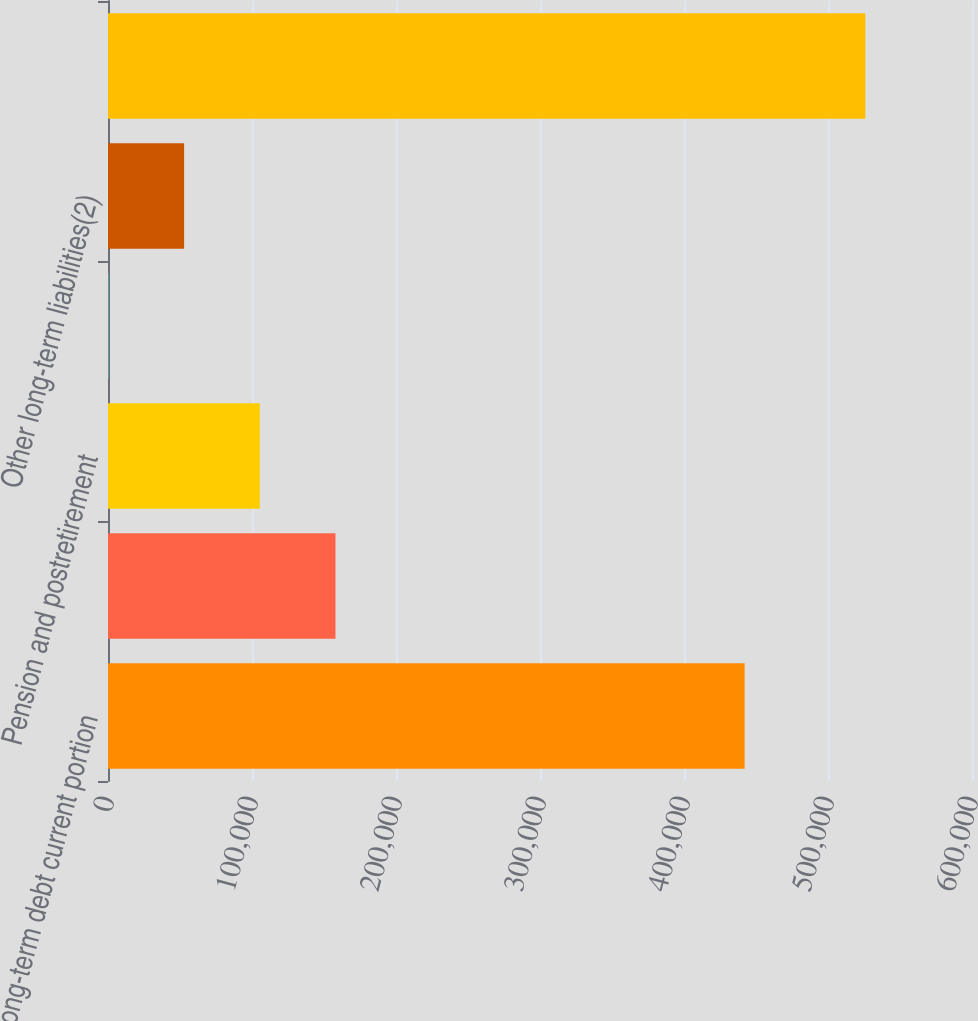Convert chart to OTSL. <chart><loc_0><loc_0><loc_500><loc_500><bar_chart><fcel>Long-term debt current portion<fcel>Operating leases<fcel>Pension and postretirement<fcel>Capital lease obligations<fcel>Other long-term liabilities(2)<fcel>Total(3)<nl><fcel>442083<fcel>157970<fcel>105404<fcel>273<fcel>52838.7<fcel>525930<nl></chart> 